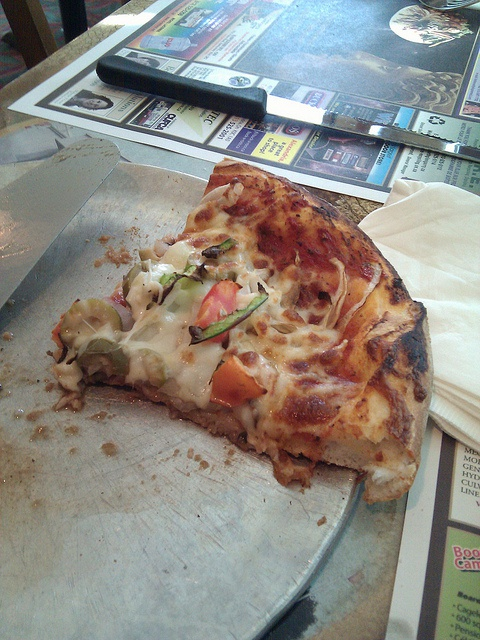Describe the objects in this image and their specific colors. I can see pizza in black, gray, maroon, tan, and brown tones and knife in black, gray, white, and blue tones in this image. 